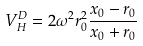Convert formula to latex. <formula><loc_0><loc_0><loc_500><loc_500>V _ { H } ^ { D } = 2 \omega ^ { 2 } r _ { 0 } ^ { 2 } \frac { x _ { 0 } - r _ { 0 } } { x _ { 0 } + r _ { 0 } }</formula> 